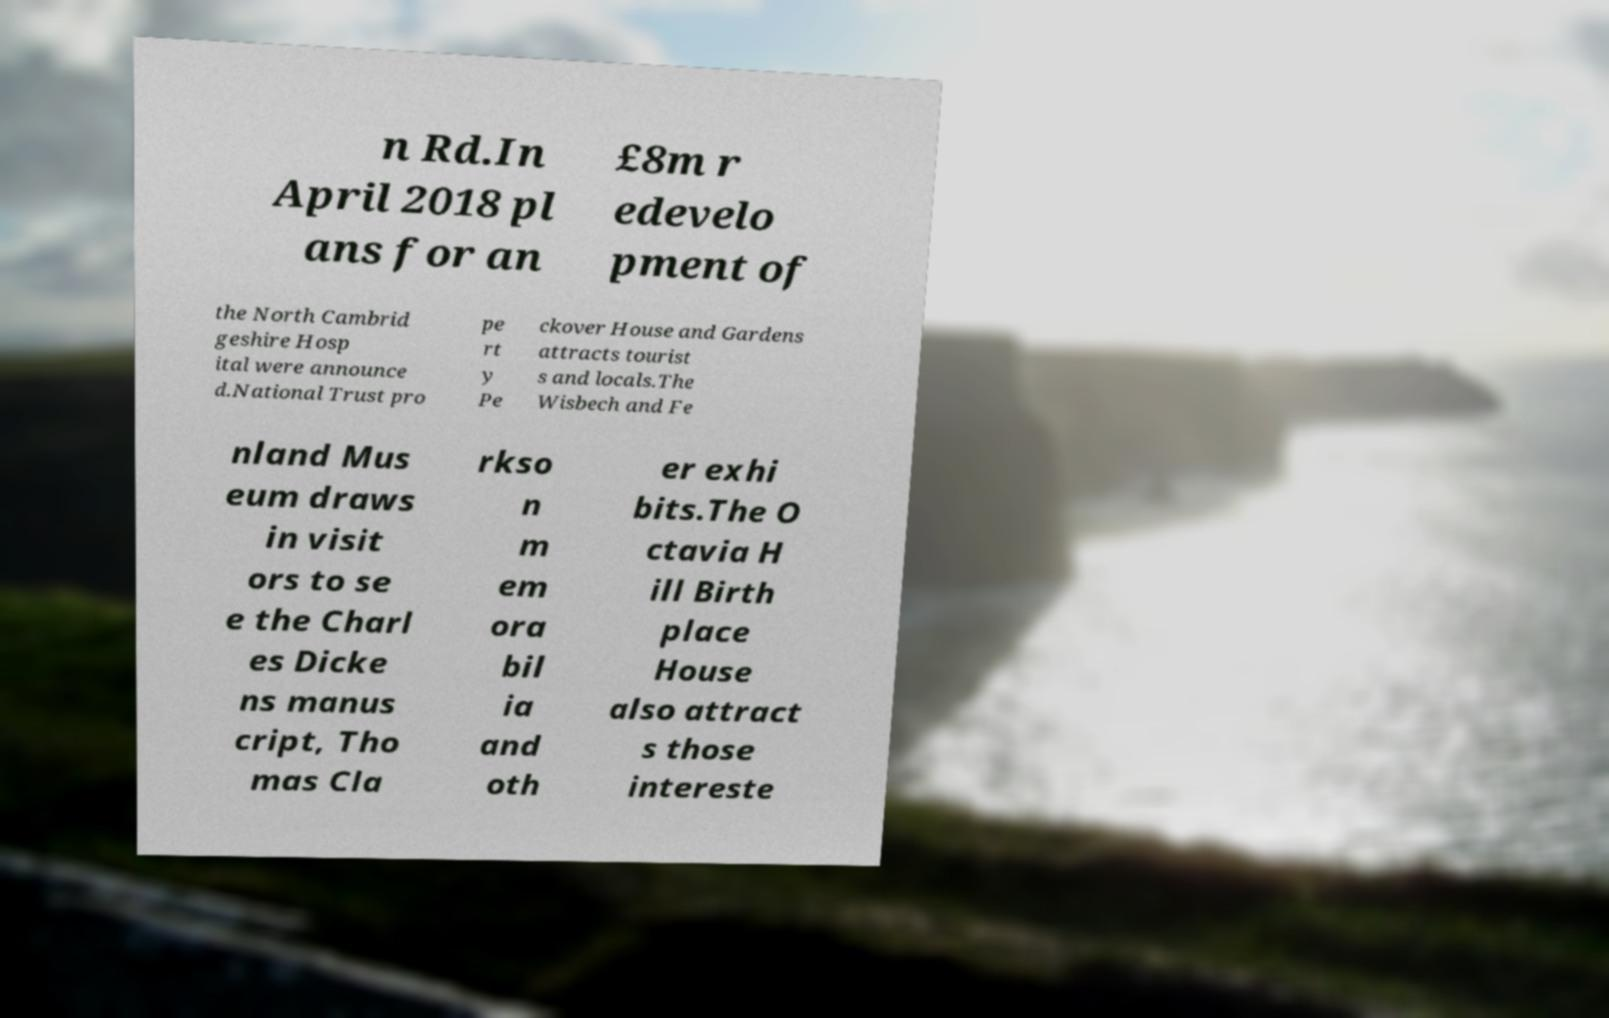Could you extract and type out the text from this image? n Rd.In April 2018 pl ans for an £8m r edevelo pment of the North Cambrid geshire Hosp ital were announce d.National Trust pro pe rt y Pe ckover House and Gardens attracts tourist s and locals.The Wisbech and Fe nland Mus eum draws in visit ors to se e the Charl es Dicke ns manus cript, Tho mas Cla rkso n m em ora bil ia and oth er exhi bits.The O ctavia H ill Birth place House also attract s those intereste 